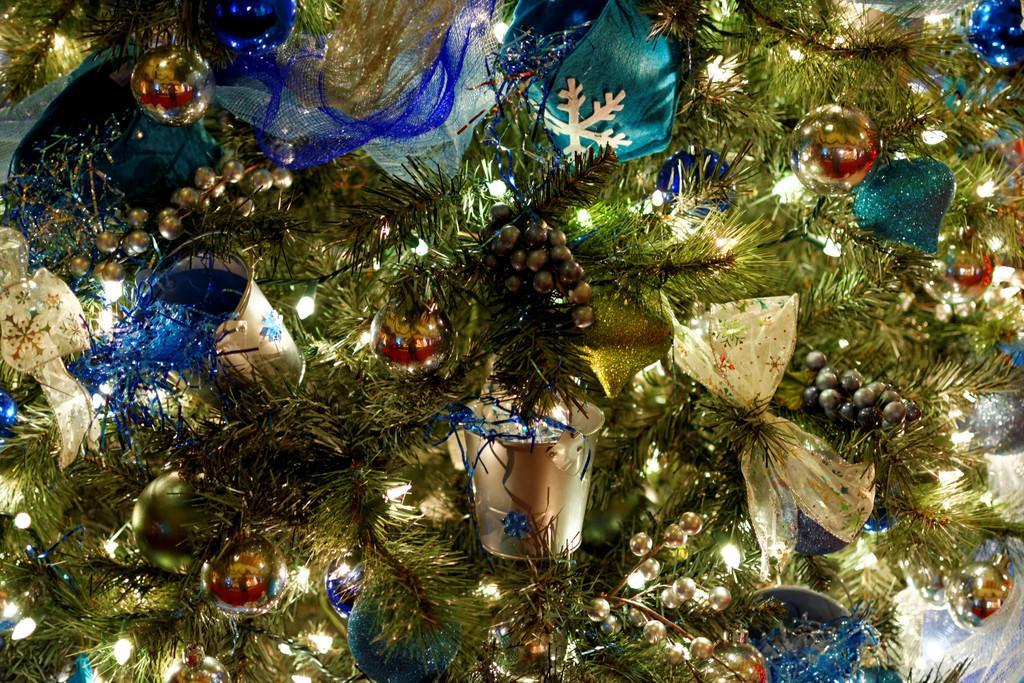Could you give a brief overview of what you see in this image? In this image we can see part of a Christmas tree with lights and decorative items. 